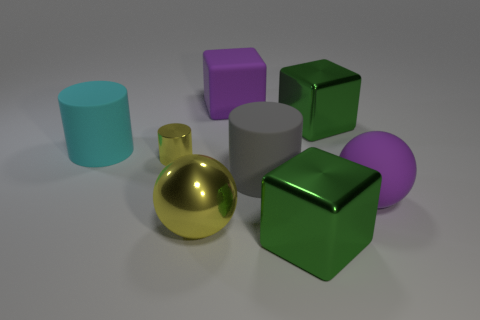Which object stands out the most and why? The golden sphere stands out the most due to its reflective surface that catches the light differently from the other objects, giving it a shiny appearance that draws the eye. What can you say about the lighting and shadows in the scene? The lighting in the scene is soft and diffused, casting gentle shadows to the right of the objects, suggesting a light source to the top-left. The smoothness of the shadows indicates an evenly lit environment without harsh direct light. 